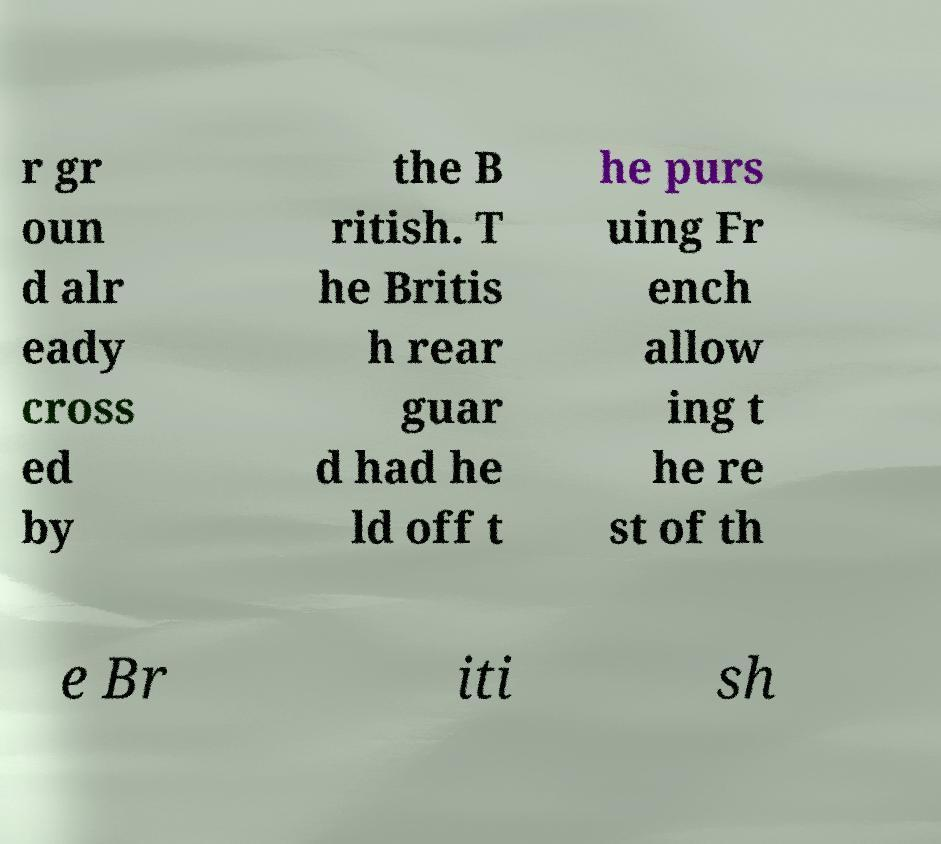Please read and relay the text visible in this image. What does it say? r gr oun d alr eady cross ed by the B ritish. T he Britis h rear guar d had he ld off t he purs uing Fr ench allow ing t he re st of th e Br iti sh 